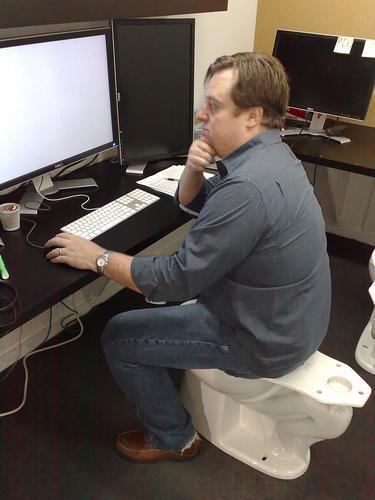How many people are in the photo?
Give a very brief answer. 1. 